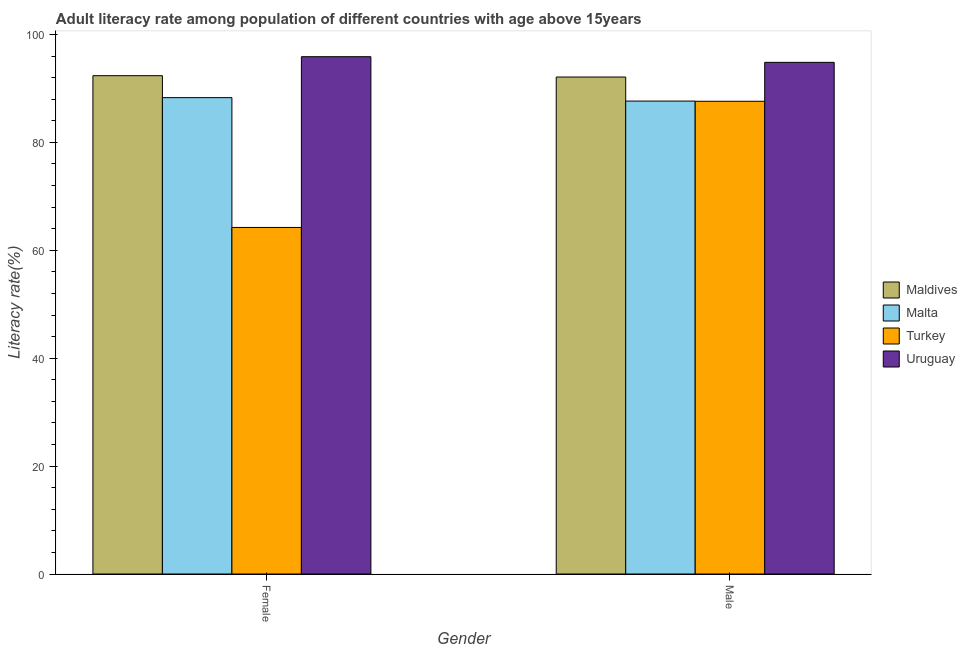How many different coloured bars are there?
Offer a terse response. 4. How many groups of bars are there?
Make the answer very short. 2. Are the number of bars on each tick of the X-axis equal?
Make the answer very short. Yes. What is the male adult literacy rate in Maldives?
Your answer should be compact. 92.11. Across all countries, what is the maximum male adult literacy rate?
Provide a succinct answer. 94.83. Across all countries, what is the minimum female adult literacy rate?
Your answer should be compact. 64.23. In which country was the female adult literacy rate maximum?
Your response must be concise. Uruguay. What is the total female adult literacy rate in the graph?
Your response must be concise. 340.77. What is the difference between the female adult literacy rate in Maldives and that in Turkey?
Your response must be concise. 28.13. What is the difference between the female adult literacy rate in Turkey and the male adult literacy rate in Uruguay?
Offer a very short reply. -30.6. What is the average female adult literacy rate per country?
Offer a terse response. 85.19. What is the difference between the male adult literacy rate and female adult literacy rate in Malta?
Offer a very short reply. -0.64. In how many countries, is the male adult literacy rate greater than 8 %?
Provide a succinct answer. 4. What is the ratio of the female adult literacy rate in Turkey to that in Maldives?
Your response must be concise. 0.7. In how many countries, is the female adult literacy rate greater than the average female adult literacy rate taken over all countries?
Provide a short and direct response. 3. What does the 2nd bar from the left in Male represents?
Provide a short and direct response. Malta. What does the 3rd bar from the right in Male represents?
Your answer should be very brief. Malta. Are all the bars in the graph horizontal?
Give a very brief answer. No. How many countries are there in the graph?
Keep it short and to the point. 4. Does the graph contain grids?
Make the answer very short. No. How many legend labels are there?
Your answer should be compact. 4. How are the legend labels stacked?
Offer a terse response. Vertical. What is the title of the graph?
Your answer should be compact. Adult literacy rate among population of different countries with age above 15years. What is the label or title of the X-axis?
Provide a short and direct response. Gender. What is the label or title of the Y-axis?
Give a very brief answer. Literacy rate(%). What is the Literacy rate(%) in Maldives in Female?
Offer a very short reply. 92.36. What is the Literacy rate(%) in Malta in Female?
Offer a very short reply. 88.29. What is the Literacy rate(%) of Turkey in Female?
Offer a terse response. 64.23. What is the Literacy rate(%) of Uruguay in Female?
Keep it short and to the point. 95.88. What is the Literacy rate(%) of Maldives in Male?
Provide a succinct answer. 92.11. What is the Literacy rate(%) in Malta in Male?
Your answer should be compact. 87.66. What is the Literacy rate(%) in Turkey in Male?
Keep it short and to the point. 87.62. What is the Literacy rate(%) of Uruguay in Male?
Keep it short and to the point. 94.83. Across all Gender, what is the maximum Literacy rate(%) of Maldives?
Give a very brief answer. 92.36. Across all Gender, what is the maximum Literacy rate(%) of Malta?
Provide a short and direct response. 88.29. Across all Gender, what is the maximum Literacy rate(%) of Turkey?
Provide a short and direct response. 87.62. Across all Gender, what is the maximum Literacy rate(%) of Uruguay?
Keep it short and to the point. 95.88. Across all Gender, what is the minimum Literacy rate(%) in Maldives?
Your response must be concise. 92.11. Across all Gender, what is the minimum Literacy rate(%) of Malta?
Your response must be concise. 87.66. Across all Gender, what is the minimum Literacy rate(%) in Turkey?
Your answer should be compact. 64.23. Across all Gender, what is the minimum Literacy rate(%) in Uruguay?
Provide a succinct answer. 94.83. What is the total Literacy rate(%) of Maldives in the graph?
Offer a very short reply. 184.47. What is the total Literacy rate(%) in Malta in the graph?
Your answer should be very brief. 175.95. What is the total Literacy rate(%) in Turkey in the graph?
Keep it short and to the point. 151.85. What is the total Literacy rate(%) in Uruguay in the graph?
Your response must be concise. 190.72. What is the difference between the Literacy rate(%) of Maldives in Female and that in Male?
Your answer should be compact. 0.24. What is the difference between the Literacy rate(%) of Malta in Female and that in Male?
Your response must be concise. 0.64. What is the difference between the Literacy rate(%) in Turkey in Female and that in Male?
Provide a short and direct response. -23.39. What is the difference between the Literacy rate(%) of Uruguay in Female and that in Male?
Give a very brief answer. 1.05. What is the difference between the Literacy rate(%) in Maldives in Female and the Literacy rate(%) in Malta in Male?
Your response must be concise. 4.7. What is the difference between the Literacy rate(%) in Maldives in Female and the Literacy rate(%) in Turkey in Male?
Keep it short and to the point. 4.74. What is the difference between the Literacy rate(%) of Maldives in Female and the Literacy rate(%) of Uruguay in Male?
Offer a terse response. -2.47. What is the difference between the Literacy rate(%) of Malta in Female and the Literacy rate(%) of Turkey in Male?
Provide a short and direct response. 0.67. What is the difference between the Literacy rate(%) in Malta in Female and the Literacy rate(%) in Uruguay in Male?
Keep it short and to the point. -6.54. What is the difference between the Literacy rate(%) in Turkey in Female and the Literacy rate(%) in Uruguay in Male?
Your response must be concise. -30.6. What is the average Literacy rate(%) in Maldives per Gender?
Provide a succinct answer. 92.24. What is the average Literacy rate(%) in Malta per Gender?
Provide a succinct answer. 87.97. What is the average Literacy rate(%) of Turkey per Gender?
Make the answer very short. 75.93. What is the average Literacy rate(%) of Uruguay per Gender?
Provide a short and direct response. 95.36. What is the difference between the Literacy rate(%) of Maldives and Literacy rate(%) of Malta in Female?
Offer a very short reply. 4.07. What is the difference between the Literacy rate(%) of Maldives and Literacy rate(%) of Turkey in Female?
Keep it short and to the point. 28.13. What is the difference between the Literacy rate(%) of Maldives and Literacy rate(%) of Uruguay in Female?
Provide a short and direct response. -3.52. What is the difference between the Literacy rate(%) of Malta and Literacy rate(%) of Turkey in Female?
Ensure brevity in your answer.  24.06. What is the difference between the Literacy rate(%) of Malta and Literacy rate(%) of Uruguay in Female?
Offer a terse response. -7.59. What is the difference between the Literacy rate(%) of Turkey and Literacy rate(%) of Uruguay in Female?
Offer a very short reply. -31.65. What is the difference between the Literacy rate(%) of Maldives and Literacy rate(%) of Malta in Male?
Provide a short and direct response. 4.46. What is the difference between the Literacy rate(%) in Maldives and Literacy rate(%) in Turkey in Male?
Keep it short and to the point. 4.49. What is the difference between the Literacy rate(%) in Maldives and Literacy rate(%) in Uruguay in Male?
Your response must be concise. -2.72. What is the difference between the Literacy rate(%) of Malta and Literacy rate(%) of Turkey in Male?
Make the answer very short. 0.04. What is the difference between the Literacy rate(%) of Malta and Literacy rate(%) of Uruguay in Male?
Your response must be concise. -7.18. What is the difference between the Literacy rate(%) of Turkey and Literacy rate(%) of Uruguay in Male?
Give a very brief answer. -7.21. What is the ratio of the Literacy rate(%) of Maldives in Female to that in Male?
Ensure brevity in your answer.  1. What is the ratio of the Literacy rate(%) in Malta in Female to that in Male?
Your answer should be compact. 1.01. What is the ratio of the Literacy rate(%) of Turkey in Female to that in Male?
Your response must be concise. 0.73. What is the ratio of the Literacy rate(%) of Uruguay in Female to that in Male?
Keep it short and to the point. 1.01. What is the difference between the highest and the second highest Literacy rate(%) in Maldives?
Offer a very short reply. 0.24. What is the difference between the highest and the second highest Literacy rate(%) of Malta?
Make the answer very short. 0.64. What is the difference between the highest and the second highest Literacy rate(%) in Turkey?
Provide a short and direct response. 23.39. What is the difference between the highest and the second highest Literacy rate(%) of Uruguay?
Give a very brief answer. 1.05. What is the difference between the highest and the lowest Literacy rate(%) of Maldives?
Ensure brevity in your answer.  0.24. What is the difference between the highest and the lowest Literacy rate(%) of Malta?
Your answer should be compact. 0.64. What is the difference between the highest and the lowest Literacy rate(%) in Turkey?
Your answer should be very brief. 23.39. What is the difference between the highest and the lowest Literacy rate(%) of Uruguay?
Offer a very short reply. 1.05. 